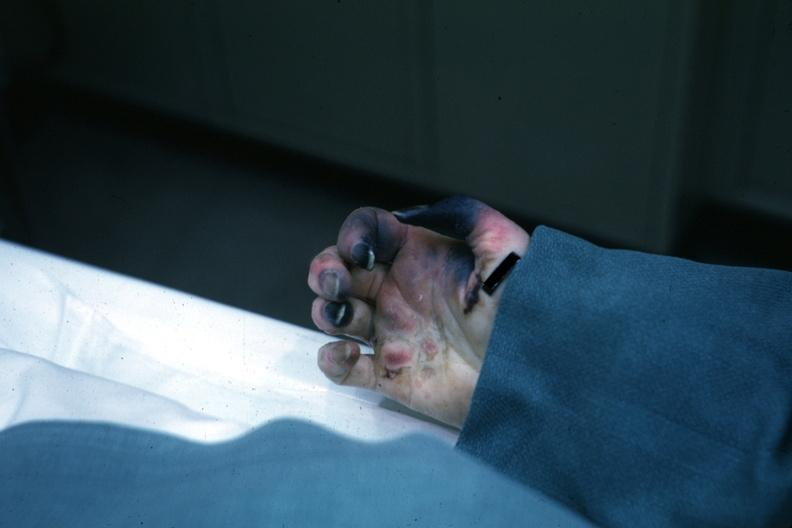what is present?
Answer the question using a single word or phrase. Hand 